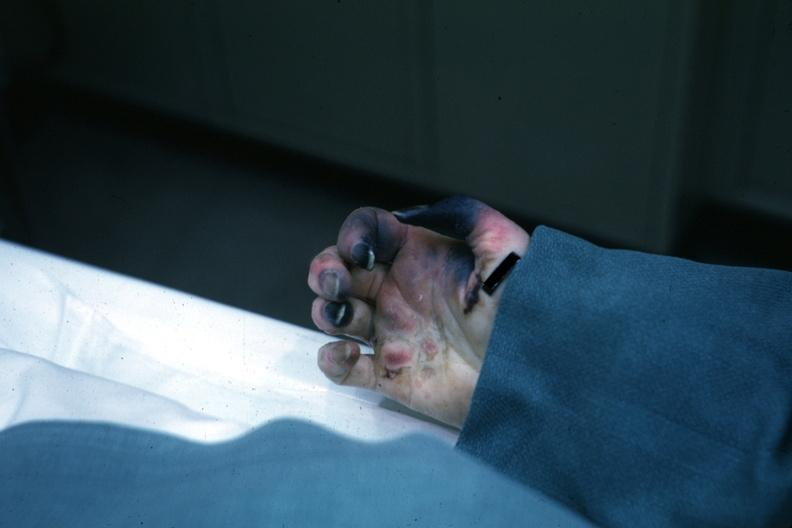what is present?
Answer the question using a single word or phrase. Hand 